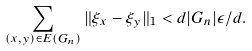Convert formula to latex. <formula><loc_0><loc_0><loc_500><loc_500>\sum _ { ( x , y ) \in E ( G _ { n } ) } \| \xi _ { x } - \xi _ { y } \| _ { 1 } < d | G _ { n } | \epsilon / d .</formula> 